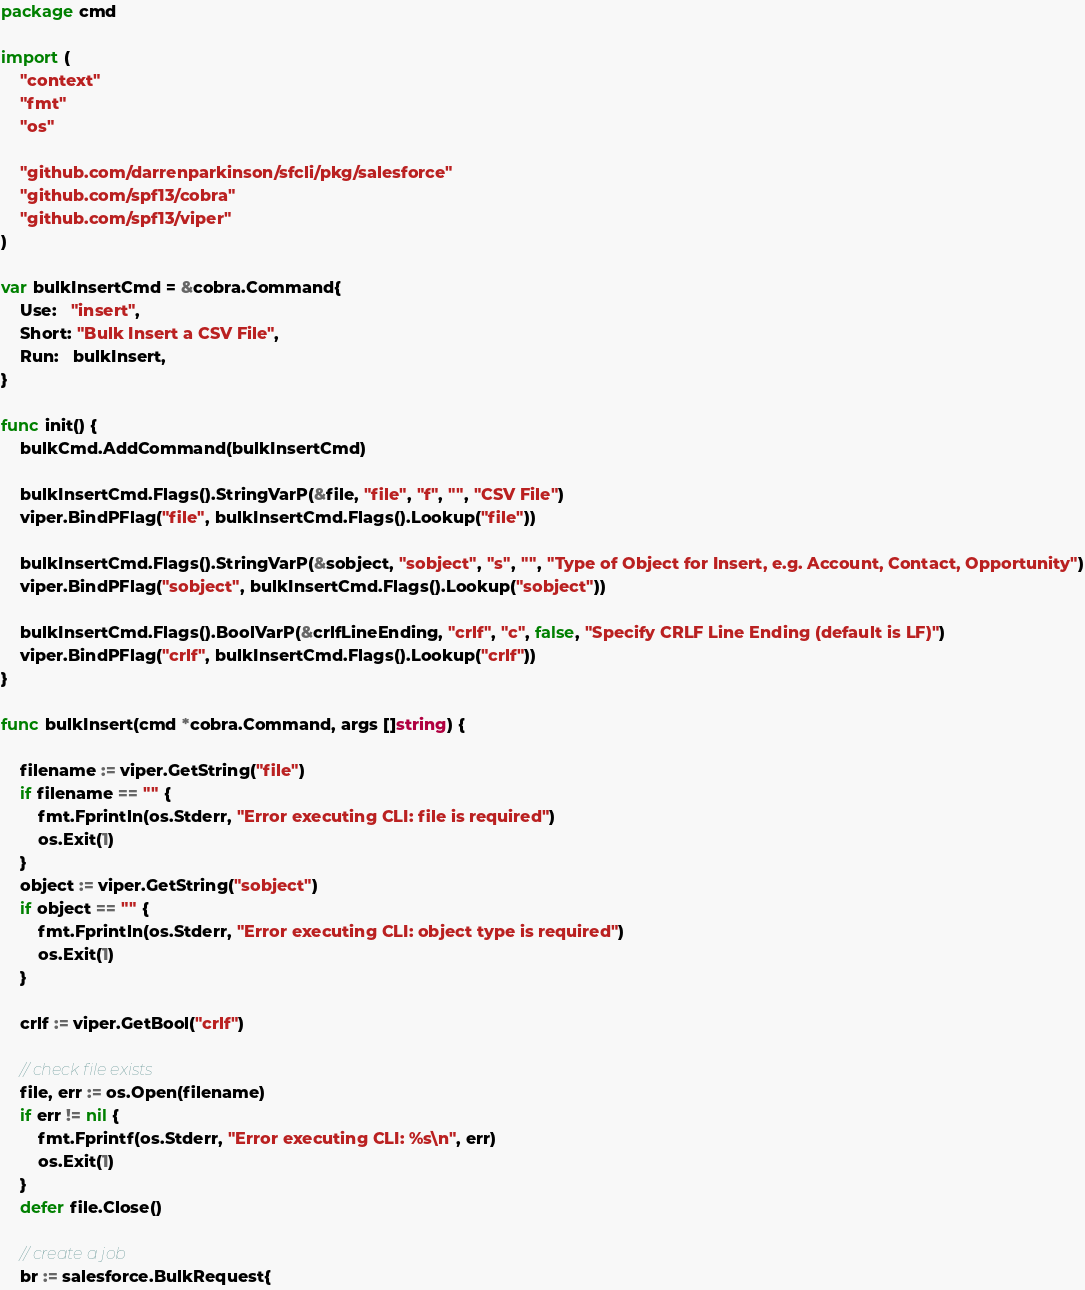Convert code to text. <code><loc_0><loc_0><loc_500><loc_500><_Go_>package cmd

import (
	"context"
	"fmt"
	"os"

	"github.com/darrenparkinson/sfcli/pkg/salesforce"
	"github.com/spf13/cobra"
	"github.com/spf13/viper"
)

var bulkInsertCmd = &cobra.Command{
	Use:   "insert",
	Short: "Bulk Insert a CSV File",
	Run:   bulkInsert,
}

func init() {
	bulkCmd.AddCommand(bulkInsertCmd)

	bulkInsertCmd.Flags().StringVarP(&file, "file", "f", "", "CSV File")
	viper.BindPFlag("file", bulkInsertCmd.Flags().Lookup("file"))

	bulkInsertCmd.Flags().StringVarP(&sobject, "sobject", "s", "", "Type of Object for Insert, e.g. Account, Contact, Opportunity")
	viper.BindPFlag("sobject", bulkInsertCmd.Flags().Lookup("sobject"))

	bulkInsertCmd.Flags().BoolVarP(&crlfLineEnding, "crlf", "c", false, "Specify CRLF Line Ending (default is LF)")
	viper.BindPFlag("crlf", bulkInsertCmd.Flags().Lookup("crlf"))
}

func bulkInsert(cmd *cobra.Command, args []string) {

	filename := viper.GetString("file")
	if filename == "" {
		fmt.Fprintln(os.Stderr, "Error executing CLI: file is required")
		os.Exit(1)
	}
	object := viper.GetString("sobject")
	if object == "" {
		fmt.Fprintln(os.Stderr, "Error executing CLI: object type is required")
		os.Exit(1)
	}

	crlf := viper.GetBool("crlf")

	// check file exists
	file, err := os.Open(filename)
	if err != nil {
		fmt.Fprintf(os.Stderr, "Error executing CLI: %s\n", err)
		os.Exit(1)
	}
	defer file.Close()

	// create a job
	br := salesforce.BulkRequest{</code> 